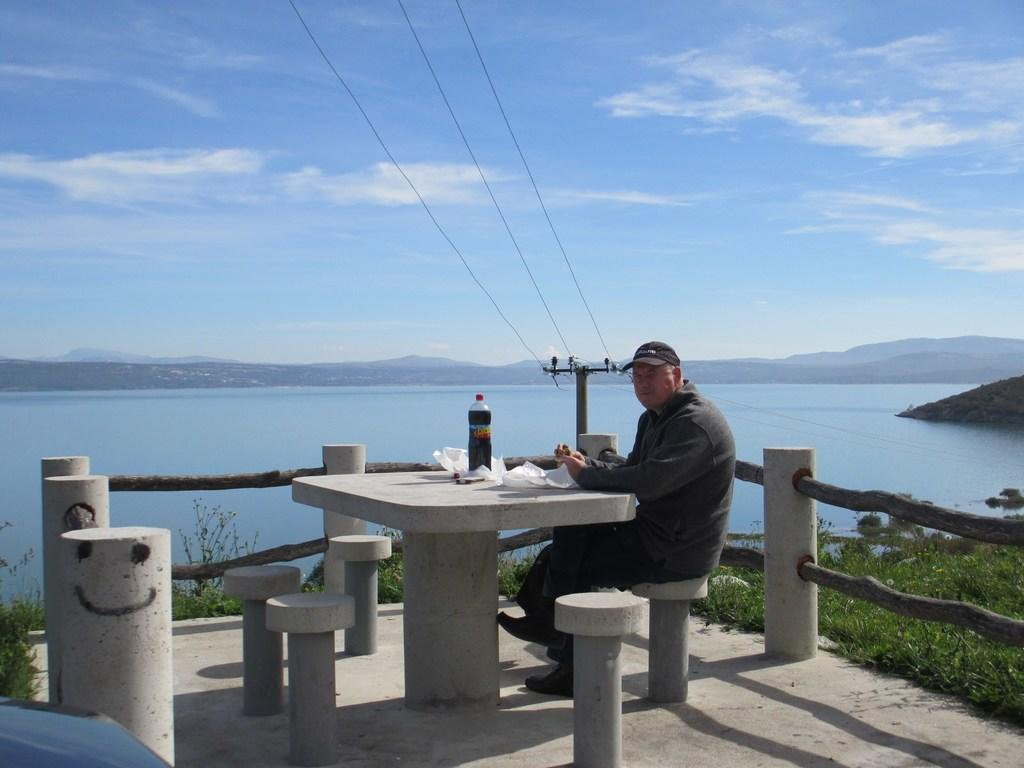What is the man in the image doing? The man is sitting in the image. What is on the table with the man? There is a bottle and papers on the table. What can be seen in the background of the image? There is water, plants, and a pole visible in the image. How is the sky depicted in the image? The sky is blue and cloudy in the image. How many vans are parked near the pole in the image? There are no vans present in the image. What type of sugar is being used to sweeten the water in the image? There is no sugar or indication of sweetening the water in the image. 